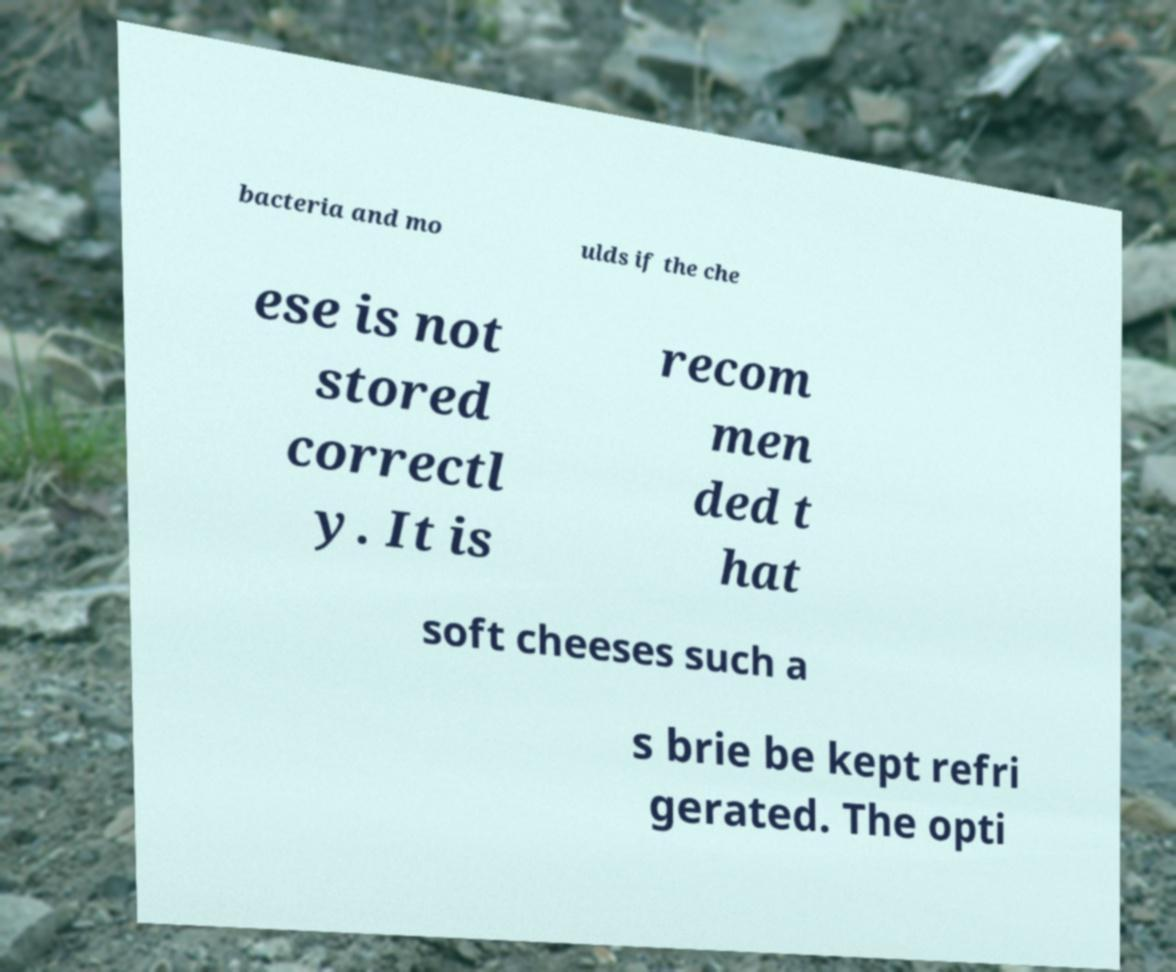Can you read and provide the text displayed in the image?This photo seems to have some interesting text. Can you extract and type it out for me? bacteria and mo ulds if the che ese is not stored correctl y. It is recom men ded t hat soft cheeses such a s brie be kept refri gerated. The opti 